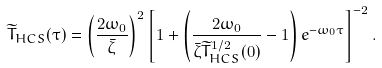Convert formula to latex. <formula><loc_0><loc_0><loc_500><loc_500>\widetilde { T } _ { H C S } ( \tau ) = \left ( \frac { 2 \omega _ { 0 } } { \bar { \zeta } } \right ) ^ { 2 } \left [ 1 + \left ( \frac { 2 \omega _ { 0 } } { \bar { \zeta } \widetilde { T } _ { H C S } ^ { 1 / 2 } ( 0 ) } - 1 \right ) e ^ { - \omega _ { 0 } \tau } \right ] ^ { - 2 } .</formula> 